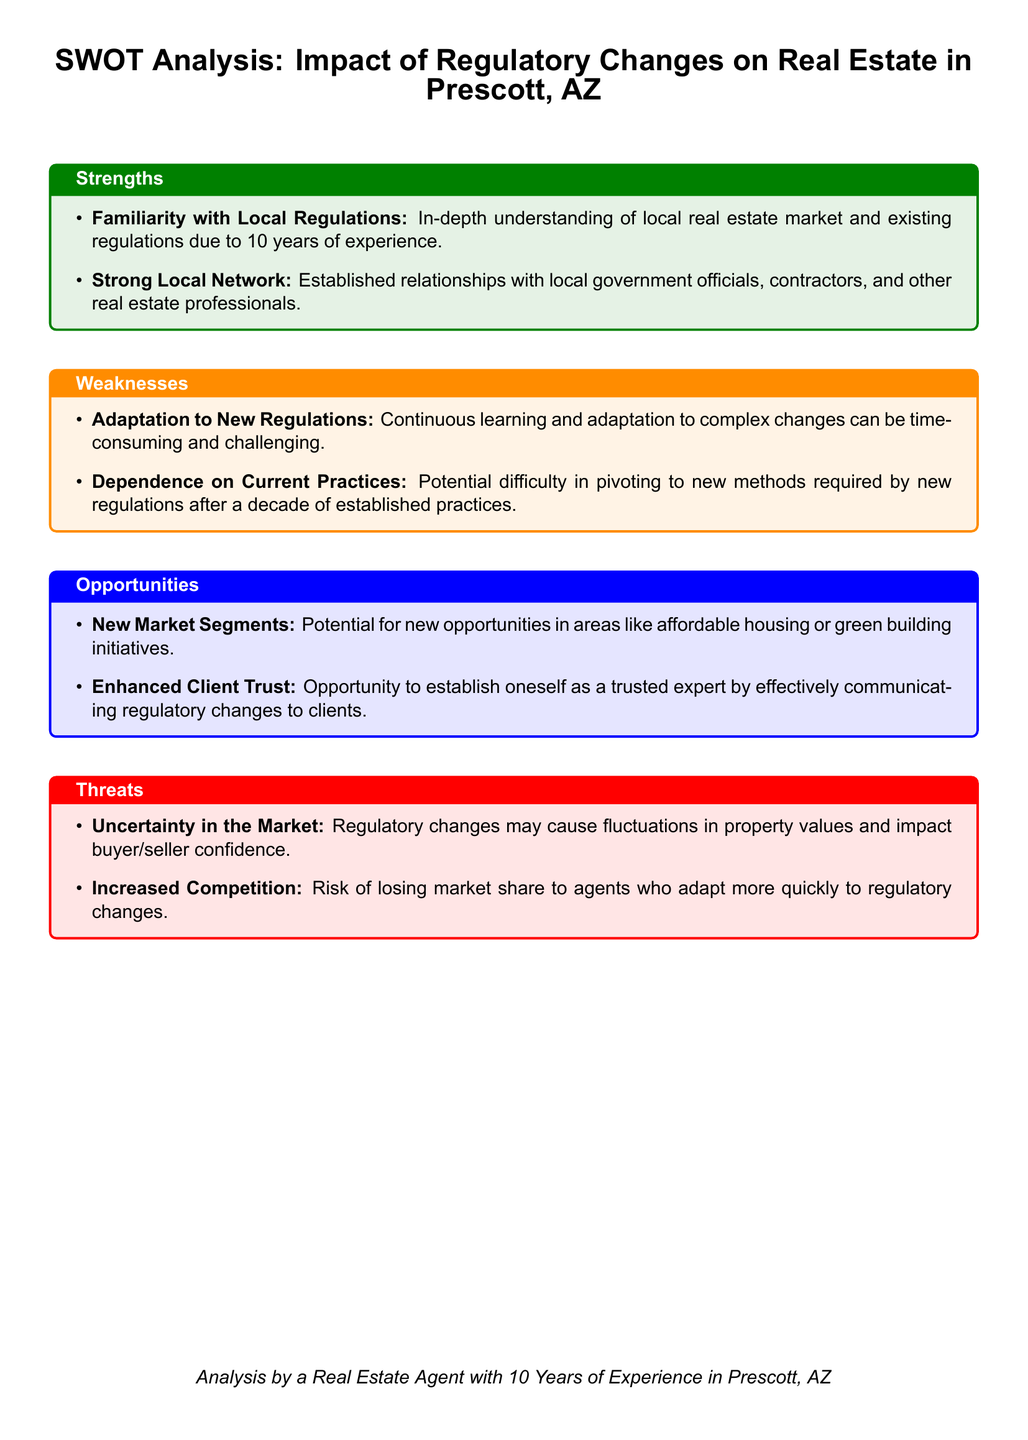What are the two strengths listed in the document? The strengths are defined in the document as "Familiarity with Local Regulations" and "Strong Local Network."
Answer: Familiarity with Local Regulations, Strong Local Network What is a potential weakness mentioned regarding adaptation? The document outlines "Adaptation to New Regulations" as a weakness, indicating that it can be time-consuming and challenging.
Answer: Adaptation to New Regulations What opportunity involves new building initiatives? The document specifies "green building initiatives" as part of the new market segments that present opportunities.
Answer: green building initiatives What is a threat related to market dynamics? The document highlights "Uncertainty in the Market" as a threat caused by regulatory changes impacting buyer and seller confidence.
Answer: Uncertainty in the Market How long has the agent worked in Prescott, AZ? The document states that the agent has worked in Prescott, AZ for "10 years," which is relevant to their expertise in the SWOT analysis.
Answer: 10 years 